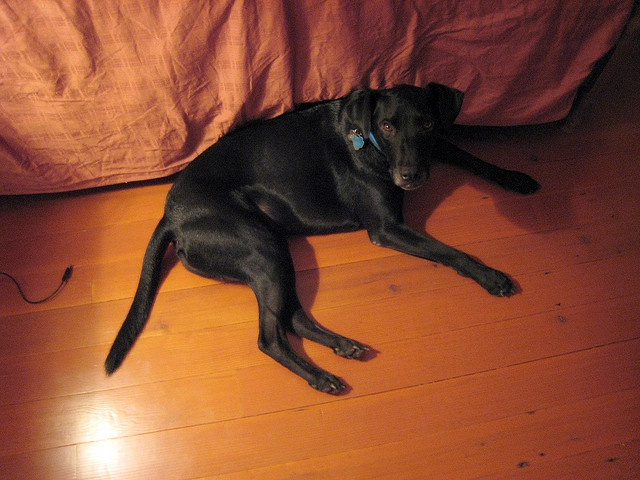Describe the objects in this image and their specific colors. I can see bed in salmon, maroon, and black tones and dog in salmon, black, maroon, and gray tones in this image. 